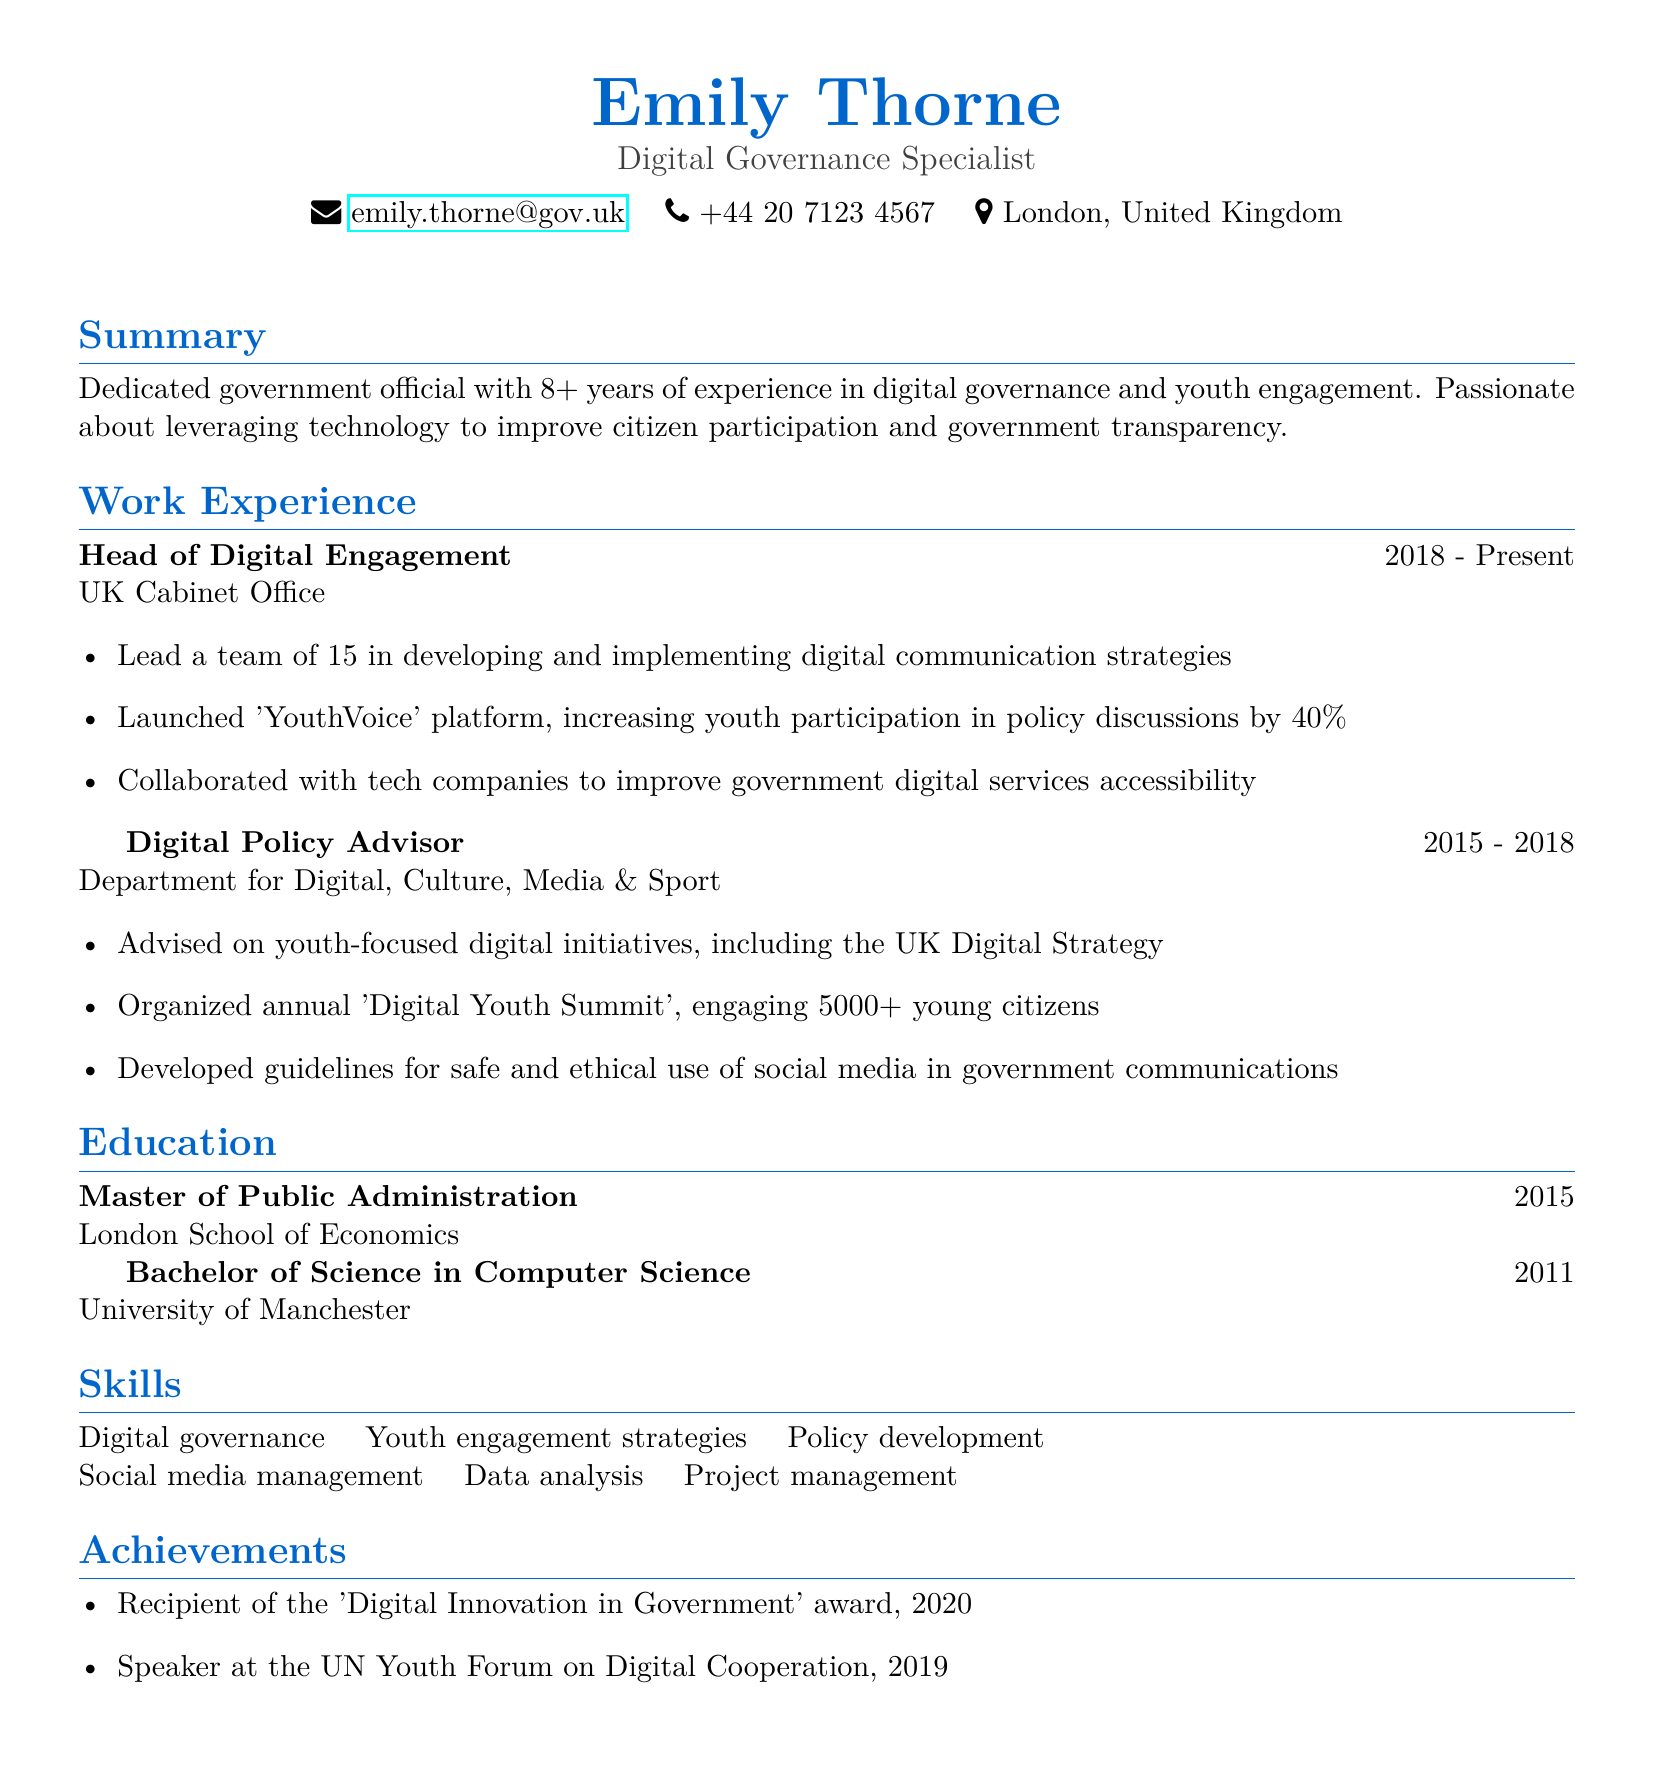What is Emily Thorne's title? Emily Thorne's title is mentioned at the top of the CV as 'Digital Governance Specialist.'
Answer: Digital Governance Specialist Which organization did Emily Thorne work for from 2018 to the present? The CV states that she is currently working for the 'UK Cabinet Office' since 2018.
Answer: UK Cabinet Office What platform did Emily launch to increase youth participation? The CV indicates that she launched the 'YouthVoice' platform to engage young citizens.
Answer: YouthVoice How many years of experience does Emily have in digital governance and youth engagement? The summary states that Emily has over 8 years of experience in these areas.
Answer: 8+ What was the focus of the annual 'Digital Youth Summit' organized by Emily? The document highlights her organization of the summit which engaged over 5000 young citizens, indicating the focus on youth engagement.
Answer: Youth engagement What award did Emily receive in 2020? The CV lists that she was the recipient of the 'Digital Innovation in Government' award in 2020.
Answer: Digital Innovation in Government In which year did Emily complete her Master's degree? According to the education section, Emily completed her Master's degree in Public Administration in 2015.
Answer: 2015 What is one of Emily's skills related to communication? The skills section mentions 'Social media management' as one of her capabilities related to communication.
Answer: Social media management How many young citizens did the 'Digital Youth Summit' engage? The document specifies that the summit engaged more than 5000 young citizens.
Answer: 5000+ 